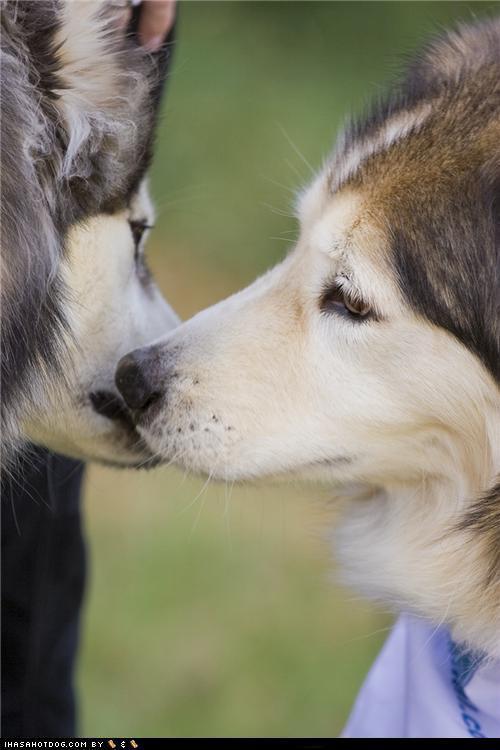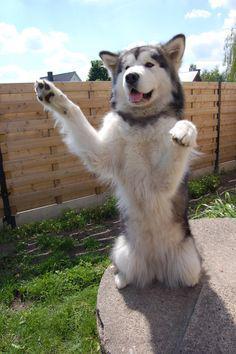The first image is the image on the left, the second image is the image on the right. Examine the images to the left and right. Is the description "Two of the huskies are touching faces with each other in snowy weather." accurate? Answer yes or no. No. The first image is the image on the left, the second image is the image on the right. Analyze the images presented: Is the assertion "One image shows two 'real' husky dogs posed face-to-face with noses close together and snow on some fur, and the other image includes one dog with its body turned rightward." valid? Answer yes or no. No. 